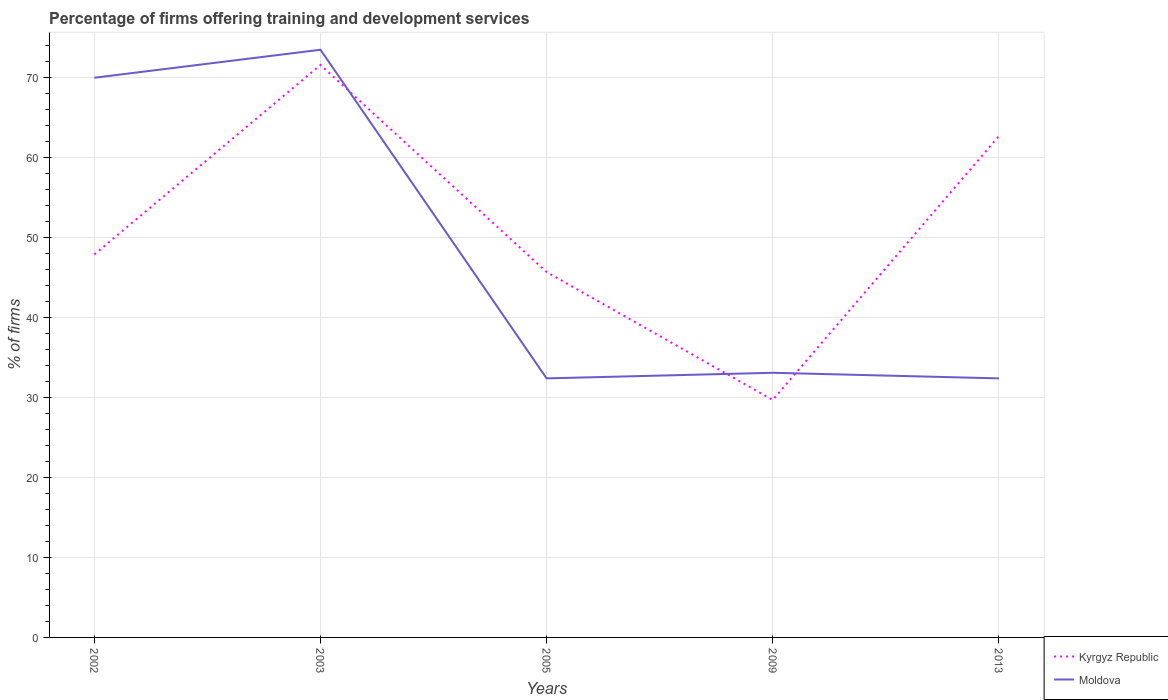Does the line corresponding to Kyrgyz Republic intersect with the line corresponding to Moldova?
Offer a very short reply. Yes. Is the number of lines equal to the number of legend labels?
Your response must be concise. Yes. Across all years, what is the maximum percentage of firms offering training and development in Kyrgyz Republic?
Your response must be concise. 29.7. What is the difference between the highest and the second highest percentage of firms offering training and development in Moldova?
Make the answer very short. 41.1. What is the difference between the highest and the lowest percentage of firms offering training and development in Moldova?
Ensure brevity in your answer.  2. What is the difference between two consecutive major ticks on the Y-axis?
Offer a terse response. 10. Are the values on the major ticks of Y-axis written in scientific E-notation?
Provide a succinct answer. No. Does the graph contain grids?
Ensure brevity in your answer.  Yes. Where does the legend appear in the graph?
Your answer should be very brief. Bottom right. How many legend labels are there?
Your response must be concise. 2. What is the title of the graph?
Keep it short and to the point. Percentage of firms offering training and development services. What is the label or title of the Y-axis?
Offer a terse response. % of firms. What is the % of firms of Kyrgyz Republic in 2002?
Give a very brief answer. 47.9. What is the % of firms in Moldova in 2002?
Make the answer very short. 70. What is the % of firms of Kyrgyz Republic in 2003?
Make the answer very short. 71.6. What is the % of firms of Moldova in 2003?
Offer a terse response. 73.5. What is the % of firms in Kyrgyz Republic in 2005?
Give a very brief answer. 45.7. What is the % of firms of Moldova in 2005?
Make the answer very short. 32.4. What is the % of firms in Kyrgyz Republic in 2009?
Give a very brief answer. 29.7. What is the % of firms of Moldova in 2009?
Your answer should be very brief. 33.1. What is the % of firms of Kyrgyz Republic in 2013?
Make the answer very short. 62.7. What is the % of firms of Moldova in 2013?
Offer a very short reply. 32.4. Across all years, what is the maximum % of firms in Kyrgyz Republic?
Ensure brevity in your answer.  71.6. Across all years, what is the maximum % of firms of Moldova?
Give a very brief answer. 73.5. Across all years, what is the minimum % of firms of Kyrgyz Republic?
Keep it short and to the point. 29.7. Across all years, what is the minimum % of firms of Moldova?
Keep it short and to the point. 32.4. What is the total % of firms of Kyrgyz Republic in the graph?
Your response must be concise. 257.6. What is the total % of firms in Moldova in the graph?
Keep it short and to the point. 241.4. What is the difference between the % of firms of Kyrgyz Republic in 2002 and that in 2003?
Offer a terse response. -23.7. What is the difference between the % of firms of Moldova in 2002 and that in 2003?
Your answer should be compact. -3.5. What is the difference between the % of firms in Moldova in 2002 and that in 2005?
Your answer should be compact. 37.6. What is the difference between the % of firms in Moldova in 2002 and that in 2009?
Your answer should be compact. 36.9. What is the difference between the % of firms of Kyrgyz Republic in 2002 and that in 2013?
Your answer should be compact. -14.8. What is the difference between the % of firms in Moldova in 2002 and that in 2013?
Ensure brevity in your answer.  37.6. What is the difference between the % of firms of Kyrgyz Republic in 2003 and that in 2005?
Your response must be concise. 25.9. What is the difference between the % of firms of Moldova in 2003 and that in 2005?
Your answer should be very brief. 41.1. What is the difference between the % of firms of Kyrgyz Republic in 2003 and that in 2009?
Your answer should be compact. 41.9. What is the difference between the % of firms of Moldova in 2003 and that in 2009?
Offer a terse response. 40.4. What is the difference between the % of firms of Kyrgyz Republic in 2003 and that in 2013?
Offer a very short reply. 8.9. What is the difference between the % of firms of Moldova in 2003 and that in 2013?
Keep it short and to the point. 41.1. What is the difference between the % of firms of Kyrgyz Republic in 2005 and that in 2009?
Your answer should be compact. 16. What is the difference between the % of firms in Moldova in 2005 and that in 2009?
Provide a short and direct response. -0.7. What is the difference between the % of firms of Kyrgyz Republic in 2005 and that in 2013?
Your answer should be very brief. -17. What is the difference between the % of firms in Kyrgyz Republic in 2009 and that in 2013?
Offer a very short reply. -33. What is the difference between the % of firms in Moldova in 2009 and that in 2013?
Provide a succinct answer. 0.7. What is the difference between the % of firms of Kyrgyz Republic in 2002 and the % of firms of Moldova in 2003?
Offer a terse response. -25.6. What is the difference between the % of firms in Kyrgyz Republic in 2002 and the % of firms in Moldova in 2005?
Give a very brief answer. 15.5. What is the difference between the % of firms of Kyrgyz Republic in 2003 and the % of firms of Moldova in 2005?
Make the answer very short. 39.2. What is the difference between the % of firms of Kyrgyz Republic in 2003 and the % of firms of Moldova in 2009?
Ensure brevity in your answer.  38.5. What is the difference between the % of firms of Kyrgyz Republic in 2003 and the % of firms of Moldova in 2013?
Provide a short and direct response. 39.2. What is the difference between the % of firms in Kyrgyz Republic in 2005 and the % of firms in Moldova in 2013?
Keep it short and to the point. 13.3. What is the difference between the % of firms of Kyrgyz Republic in 2009 and the % of firms of Moldova in 2013?
Keep it short and to the point. -2.7. What is the average % of firms of Kyrgyz Republic per year?
Offer a terse response. 51.52. What is the average % of firms in Moldova per year?
Your response must be concise. 48.28. In the year 2002, what is the difference between the % of firms of Kyrgyz Republic and % of firms of Moldova?
Give a very brief answer. -22.1. In the year 2009, what is the difference between the % of firms in Kyrgyz Republic and % of firms in Moldova?
Your answer should be compact. -3.4. In the year 2013, what is the difference between the % of firms in Kyrgyz Republic and % of firms in Moldova?
Your response must be concise. 30.3. What is the ratio of the % of firms of Kyrgyz Republic in 2002 to that in 2003?
Offer a very short reply. 0.67. What is the ratio of the % of firms in Kyrgyz Republic in 2002 to that in 2005?
Keep it short and to the point. 1.05. What is the ratio of the % of firms in Moldova in 2002 to that in 2005?
Offer a terse response. 2.16. What is the ratio of the % of firms of Kyrgyz Republic in 2002 to that in 2009?
Keep it short and to the point. 1.61. What is the ratio of the % of firms in Moldova in 2002 to that in 2009?
Give a very brief answer. 2.11. What is the ratio of the % of firms of Kyrgyz Republic in 2002 to that in 2013?
Give a very brief answer. 0.76. What is the ratio of the % of firms of Moldova in 2002 to that in 2013?
Your response must be concise. 2.16. What is the ratio of the % of firms of Kyrgyz Republic in 2003 to that in 2005?
Your response must be concise. 1.57. What is the ratio of the % of firms of Moldova in 2003 to that in 2005?
Your answer should be compact. 2.27. What is the ratio of the % of firms in Kyrgyz Republic in 2003 to that in 2009?
Provide a succinct answer. 2.41. What is the ratio of the % of firms of Moldova in 2003 to that in 2009?
Offer a terse response. 2.22. What is the ratio of the % of firms in Kyrgyz Republic in 2003 to that in 2013?
Your answer should be compact. 1.14. What is the ratio of the % of firms in Moldova in 2003 to that in 2013?
Offer a terse response. 2.27. What is the ratio of the % of firms of Kyrgyz Republic in 2005 to that in 2009?
Your answer should be very brief. 1.54. What is the ratio of the % of firms in Moldova in 2005 to that in 2009?
Your answer should be compact. 0.98. What is the ratio of the % of firms in Kyrgyz Republic in 2005 to that in 2013?
Your response must be concise. 0.73. What is the ratio of the % of firms in Kyrgyz Republic in 2009 to that in 2013?
Ensure brevity in your answer.  0.47. What is the ratio of the % of firms of Moldova in 2009 to that in 2013?
Give a very brief answer. 1.02. What is the difference between the highest and the lowest % of firms of Kyrgyz Republic?
Your response must be concise. 41.9. What is the difference between the highest and the lowest % of firms in Moldova?
Offer a very short reply. 41.1. 